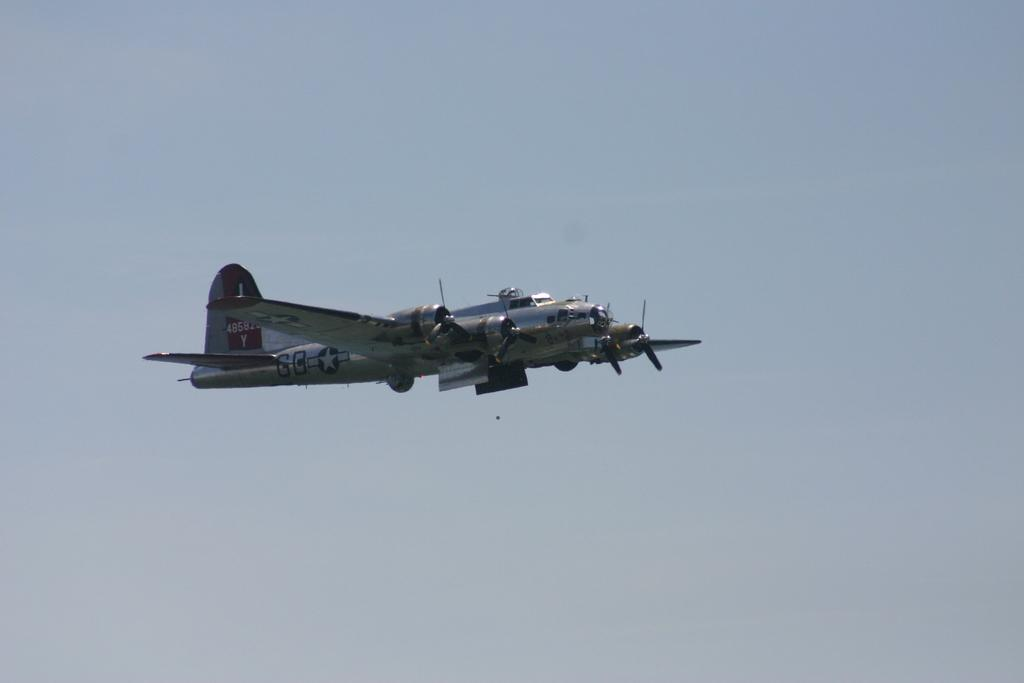<image>
Provide a brief description of the given image. A prop airplane flying with the letters GB displayed on the side. 